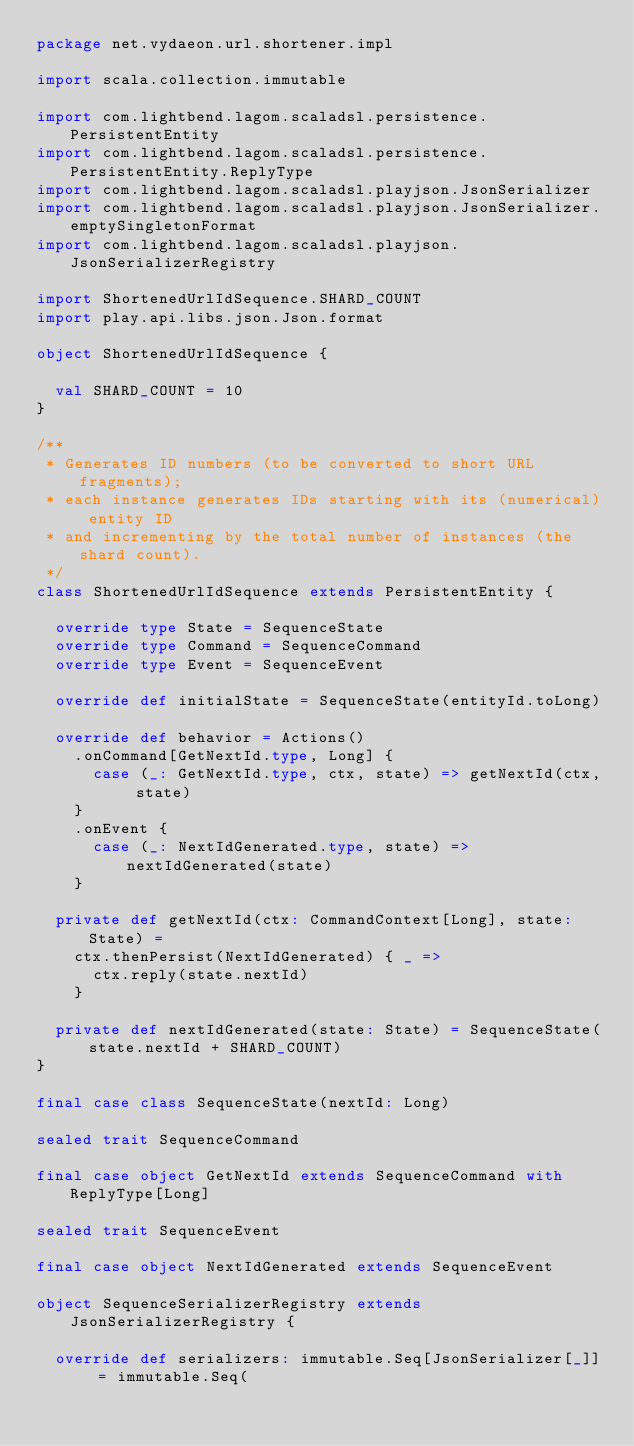Convert code to text. <code><loc_0><loc_0><loc_500><loc_500><_Scala_>package net.vydaeon.url.shortener.impl

import scala.collection.immutable

import com.lightbend.lagom.scaladsl.persistence.PersistentEntity
import com.lightbend.lagom.scaladsl.persistence.PersistentEntity.ReplyType
import com.lightbend.lagom.scaladsl.playjson.JsonSerializer
import com.lightbend.lagom.scaladsl.playjson.JsonSerializer.emptySingletonFormat
import com.lightbend.lagom.scaladsl.playjson.JsonSerializerRegistry

import ShortenedUrlIdSequence.SHARD_COUNT
import play.api.libs.json.Json.format

object ShortenedUrlIdSequence {

  val SHARD_COUNT = 10
}

/**
 * Generates ID numbers (to be converted to short URL fragments);
 * each instance generates IDs starting with its (numerical) entity ID
 * and incrementing by the total number of instances (the shard count).
 */
class ShortenedUrlIdSequence extends PersistentEntity {

  override type State = SequenceState
  override type Command = SequenceCommand
  override type Event = SequenceEvent

  override def initialState = SequenceState(entityId.toLong)

  override def behavior = Actions()
    .onCommand[GetNextId.type, Long] {
      case (_: GetNextId.type, ctx, state) => getNextId(ctx, state)
    }
    .onEvent {
      case (_: NextIdGenerated.type, state) => nextIdGenerated(state)
    }

  private def getNextId(ctx: CommandContext[Long], state: State) =
    ctx.thenPersist(NextIdGenerated) { _ =>
      ctx.reply(state.nextId)
    }

  private def nextIdGenerated(state: State) = SequenceState(state.nextId + SHARD_COUNT)
}

final case class SequenceState(nextId: Long)

sealed trait SequenceCommand

final case object GetNextId extends SequenceCommand with ReplyType[Long]

sealed trait SequenceEvent

final case object NextIdGenerated extends SequenceEvent

object SequenceSerializerRegistry extends JsonSerializerRegistry {

  override def serializers: immutable.Seq[JsonSerializer[_]] = immutable.Seq(</code> 